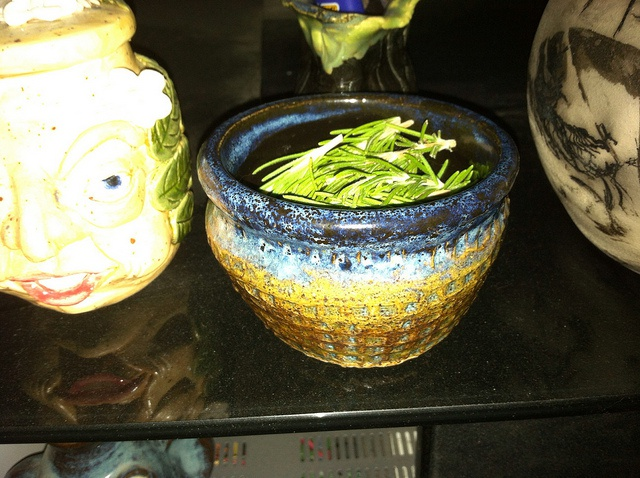Describe the objects in this image and their specific colors. I can see dining table in tan, black, olive, and gray tones, potted plant in tan, black, ivory, olive, and khaki tones, vase in tan, ivory, and khaki tones, and vase in tan, black, gray, and olive tones in this image. 